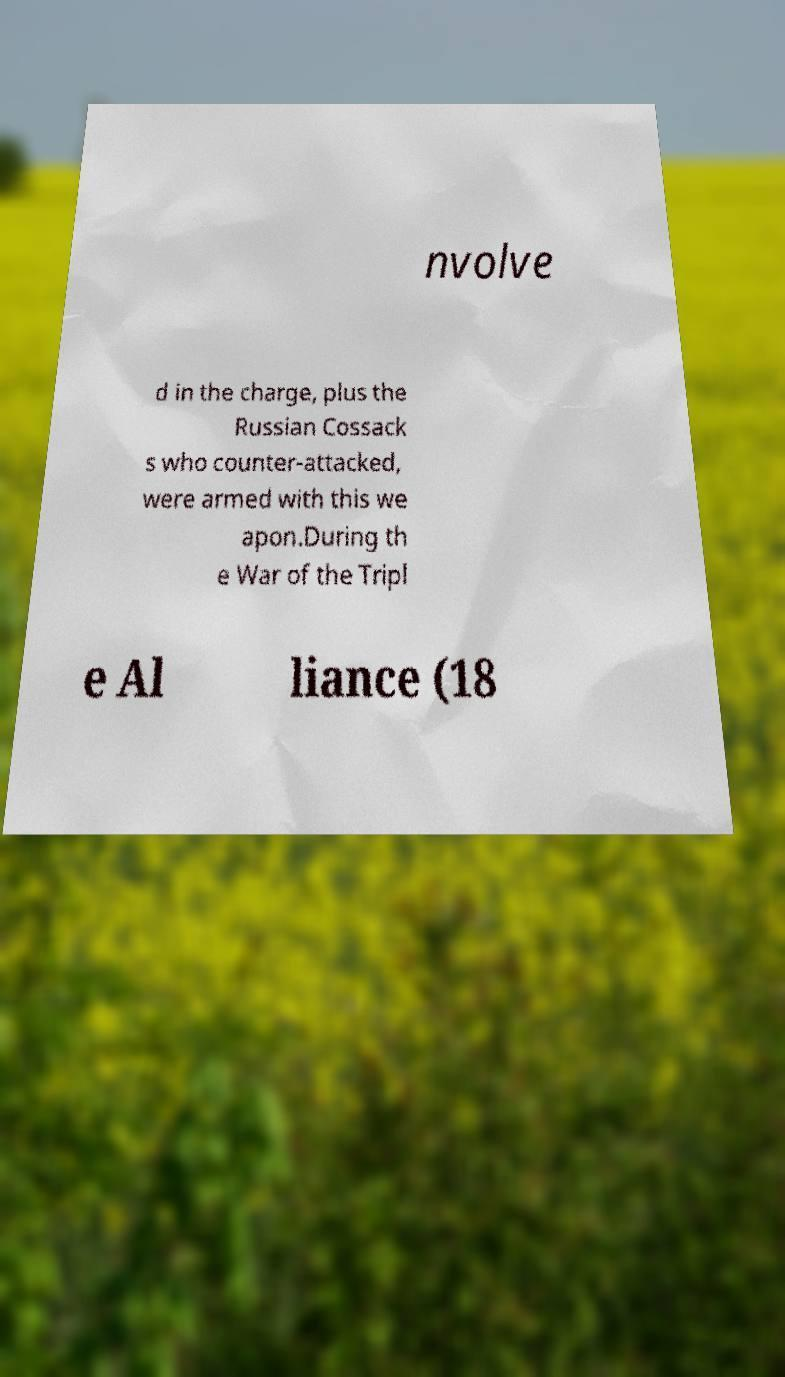Can you accurately transcribe the text from the provided image for me? nvolve d in the charge, plus the Russian Cossack s who counter-attacked, were armed with this we apon.During th e War of the Tripl e Al liance (18 